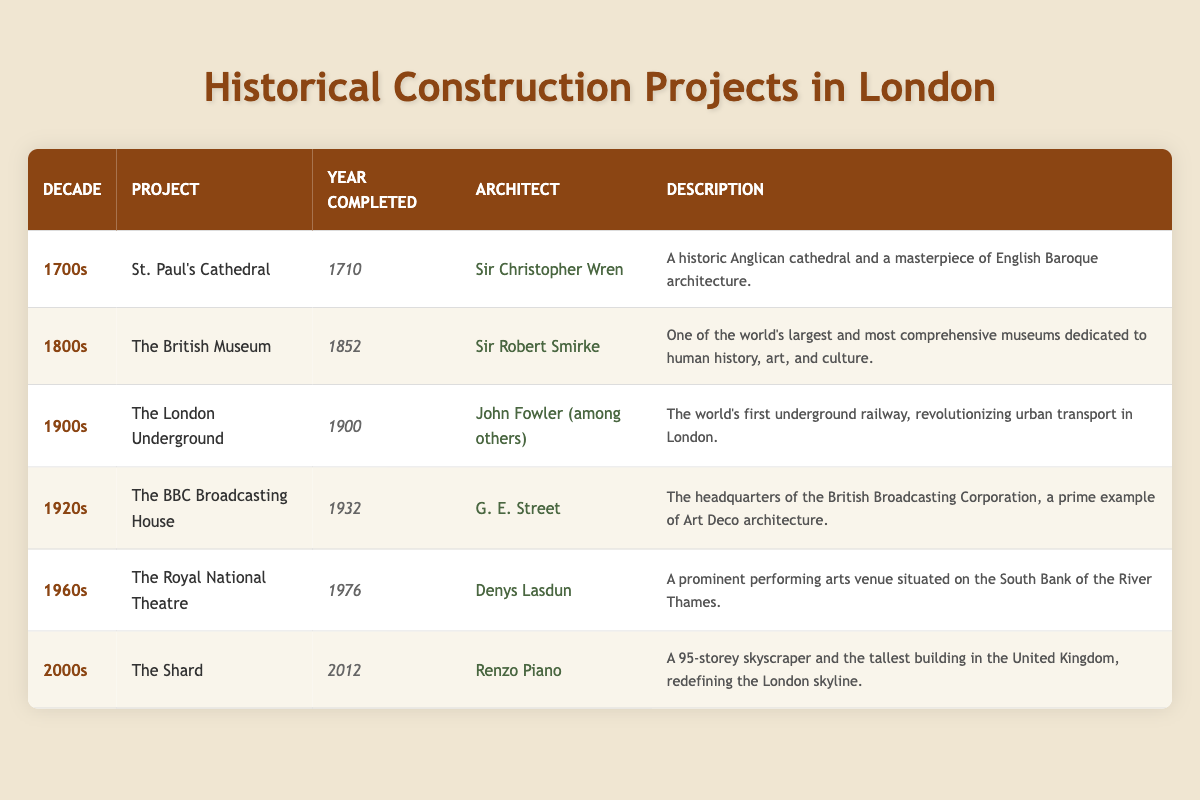What project was completed in the 1700s? The table lists several projects and their completion years. By examining the entries for the 1700s, the project displayed is St. Paul's Cathedral, which was marked with a completed year of 1710.
Answer: St. Paul's Cathedral Who was the architect of The British Museum? The table indicates the projects along with their architects. For The British Museum, looking at the entry for the 1800s, the architect is stated as Sir Robert Smirke.
Answer: Sir Robert Smirke Which project was designed by Denys Lasdun? To find this, I scanned the architects listed in the table. The entry for the Royal National Theatre, completed in 1976, shows that it was designed by Denys Lasdun.
Answer: The Royal National Theatre Were there any projects completed in the 1900s before 1920? By reviewing the projects listed for the 1900s, I see that The London Underground was completed in 1900, which is before 1920. Therefore, the answer is affirmative.
Answer: Yes What is the total number of projects listed in the table? The table has a total of six distinct projects displayed, one for each decade represented. Thus, by counting the rows under the body section, we find there are six projects listed.
Answer: 6 Was there any project that showcases Art Deco architecture? Looking specifically at the architectural description for each project, the BBC Broadcasting House, completed in 1932 and appearing in the 1920s section, is explicitly noted as a prime example of Art Deco architecture.
Answer: Yes What is the difference in years between the completion of The Shard and St. Paul's Cathedral? To find the difference in years, I take the completion year of The Shard (2012) and subtract the completion year of St. Paul's Cathedral (1710). Performing the calculation gives 2012 - 1710 = 302 years.
Answer: 302 Which two projects were completed the latest, and who were their architects? The table shows that The Shard was completed in 2012 (architect: Renzo Piano) and The Royal National Theatre was completed in 1976 (architect: Denys Lasdun). These are the two latest projects listed.
Answer: The Shard, Renzo Piano; The Royal National Theatre, Denys Lasdun Was the British Museum completed in the 1800s? By referencing the decade listings in the table, it is clear that The British Museum was indeed completed in 1852, thus confirming it was a project of the 1800s.
Answer: Yes 